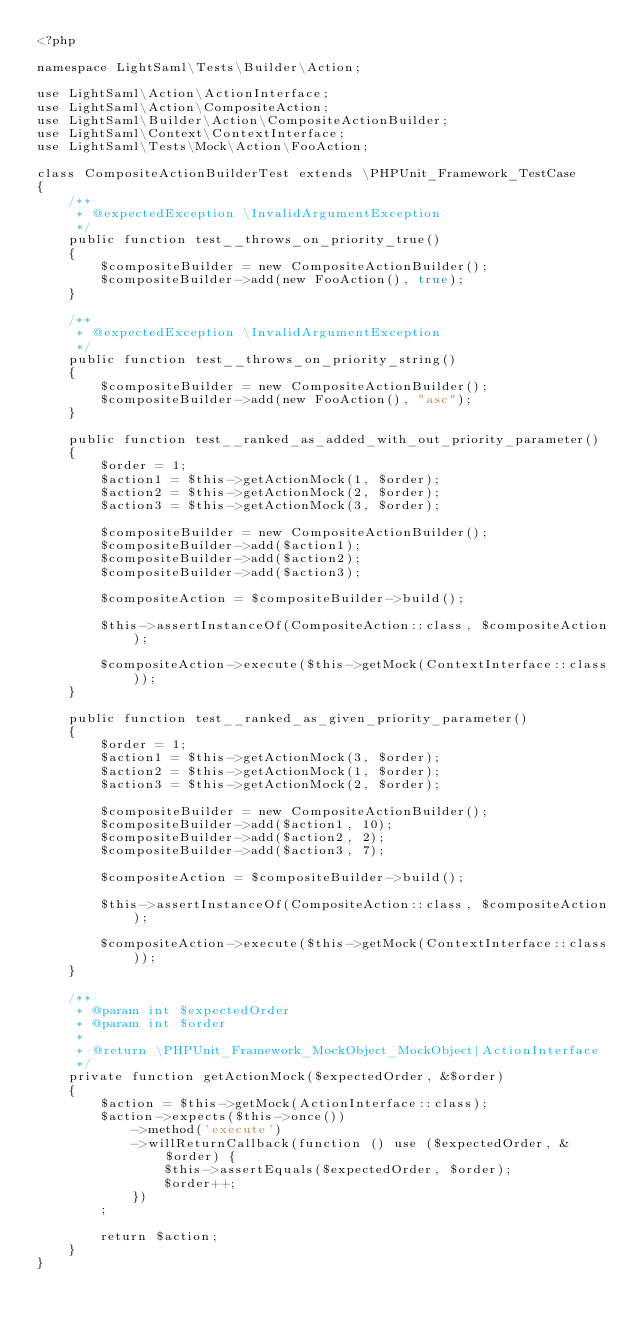Convert code to text. <code><loc_0><loc_0><loc_500><loc_500><_PHP_><?php

namespace LightSaml\Tests\Builder\Action;

use LightSaml\Action\ActionInterface;
use LightSaml\Action\CompositeAction;
use LightSaml\Builder\Action\CompositeActionBuilder;
use LightSaml\Context\ContextInterface;
use LightSaml\Tests\Mock\Action\FooAction;

class CompositeActionBuilderTest extends \PHPUnit_Framework_TestCase
{
    /**
     * @expectedException \InvalidArgumentException
     */
    public function test__throws_on_priority_true()
    {
        $compositeBuilder = new CompositeActionBuilder();
        $compositeBuilder->add(new FooAction(), true);
    }

    /**
     * @expectedException \InvalidArgumentException
     */
    public function test__throws_on_priority_string()
    {
        $compositeBuilder = new CompositeActionBuilder();
        $compositeBuilder->add(new FooAction(), "asc");
    }

    public function test__ranked_as_added_with_out_priority_parameter()
    {
        $order = 1;
        $action1 = $this->getActionMock(1, $order);
        $action2 = $this->getActionMock(2, $order);
        $action3 = $this->getActionMock(3, $order);

        $compositeBuilder = new CompositeActionBuilder();
        $compositeBuilder->add($action1);
        $compositeBuilder->add($action2);
        $compositeBuilder->add($action3);

        $compositeAction = $compositeBuilder->build();

        $this->assertInstanceOf(CompositeAction::class, $compositeAction);

        $compositeAction->execute($this->getMock(ContextInterface::class));
    }

    public function test__ranked_as_given_priority_parameter()
    {
        $order = 1;
        $action1 = $this->getActionMock(3, $order);
        $action2 = $this->getActionMock(1, $order);
        $action3 = $this->getActionMock(2, $order);

        $compositeBuilder = new CompositeActionBuilder();
        $compositeBuilder->add($action1, 10);
        $compositeBuilder->add($action2, 2);
        $compositeBuilder->add($action3, 7);

        $compositeAction = $compositeBuilder->build();

        $this->assertInstanceOf(CompositeAction::class, $compositeAction);

        $compositeAction->execute($this->getMock(ContextInterface::class));
    }

    /**
     * @param int $expectedOrder
     * @param int $order
     *
     * @return \PHPUnit_Framework_MockObject_MockObject|ActionInterface
     */
    private function getActionMock($expectedOrder, &$order)
    {
        $action = $this->getMock(ActionInterface::class);
        $action->expects($this->once())
            ->method('execute')
            ->willReturnCallback(function () use ($expectedOrder, &$order) {
                $this->assertEquals($expectedOrder, $order);
                $order++;
            })
        ;

        return $action;
    }
}
</code> 